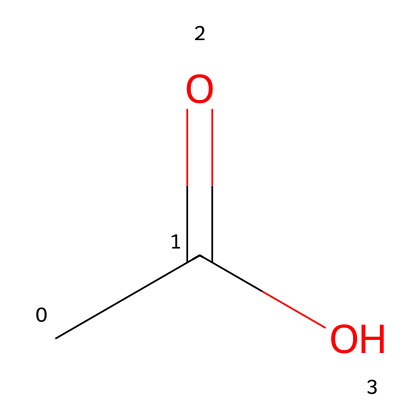What is the main functional group in this chemical? The chemical structure of acetic acid contains a carboxyl functional group, which consists of a carbon atom double bonded to an oxygen atom and singly bonded to a hydroxyl group.
Answer: carboxyl How many hydrogen atoms are present in acetic acid? By examining the structure, we see that acetic acid is composed of two carbon atoms, and since there are three hydrogen atoms directly bonded to the structure along with one in the hydroxyl group, the total is four.
Answer: four What is the molecular formula of acetic acid? The SMILES representation indicates one carbonyl group (CO), two carbons (C), and four hydrogen atoms (H). Therefore, by combining these elements, we find that the molecular formula is C2H4O2.
Answer: C2H4O2 Why does acetic acid have a sour taste? The sour taste of acetic acid is due to the presence of the carboxyl group, which can release hydrogen ions (H+) into solution, implying an acidic nature. This acidity contributes to the sour flavor.
Answer: acidic How many bonds are present in acetic acid? The structure shows one double bond between the carbon and oxygen in the carbonyl group and single bonds between carbon and hydrogen atoms and between carbon and the hydroxyl group, totaling six bonds in the entire structure.
Answer: six 